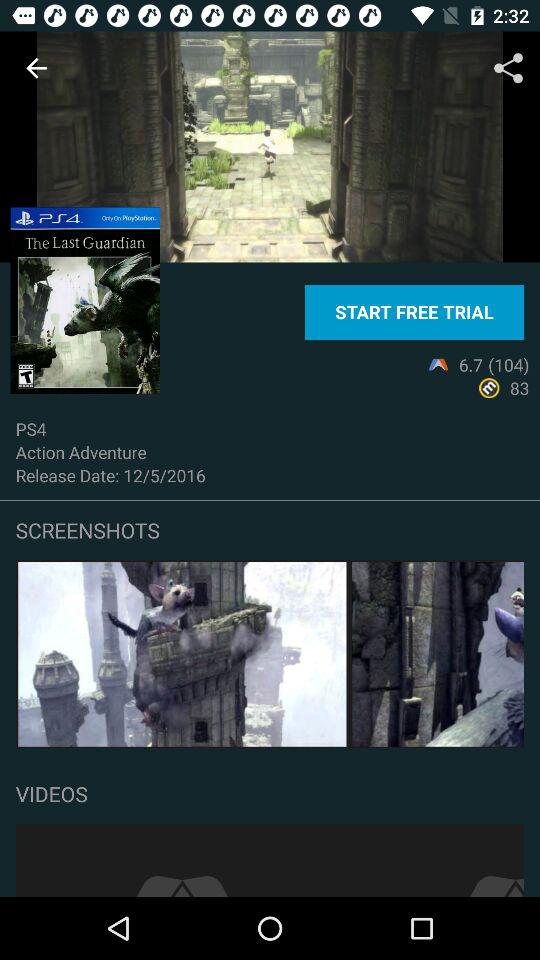What's the genre of the PS4 game "The Last Guardian"? The genre of the PS4 game is action-adventure. 